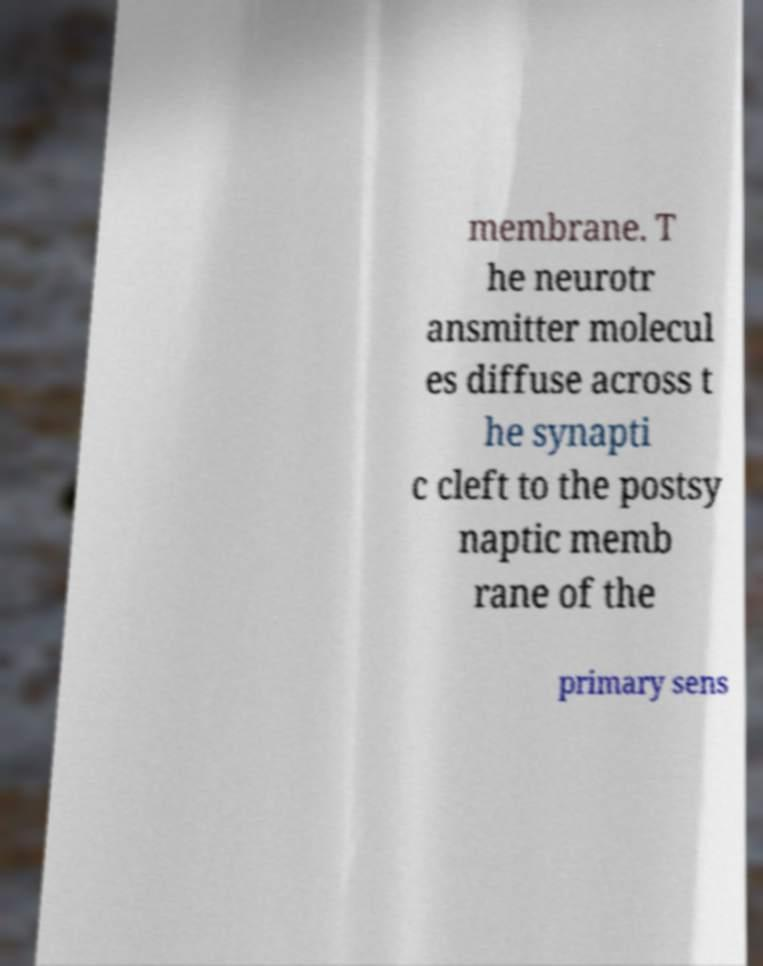I need the written content from this picture converted into text. Can you do that? membrane. T he neurotr ansmitter molecul es diffuse across t he synapti c cleft to the postsy naptic memb rane of the primary sens 